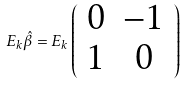Convert formula to latex. <formula><loc_0><loc_0><loc_500><loc_500>E _ { k } \hat { \beta } = E _ { k } \left ( \begin{array} { c c } 0 & - 1 \\ 1 & 0 \end{array} \right )</formula> 